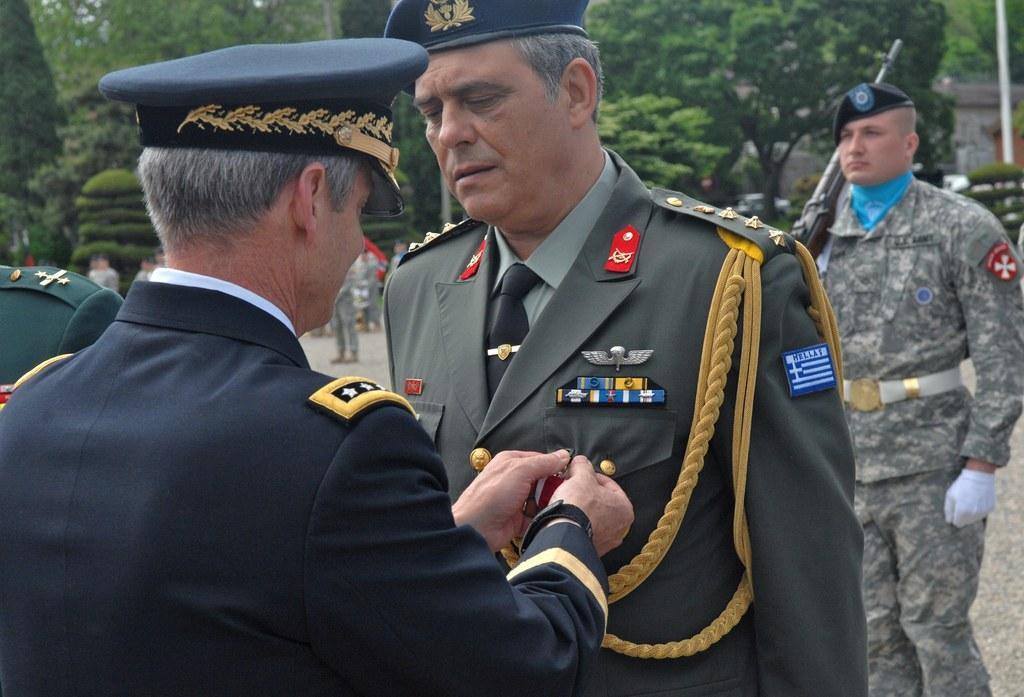How would you summarize this image in a sentence or two? In this image I can see there are two persons in the background I can see two persons and trees and a pole on the right side. 